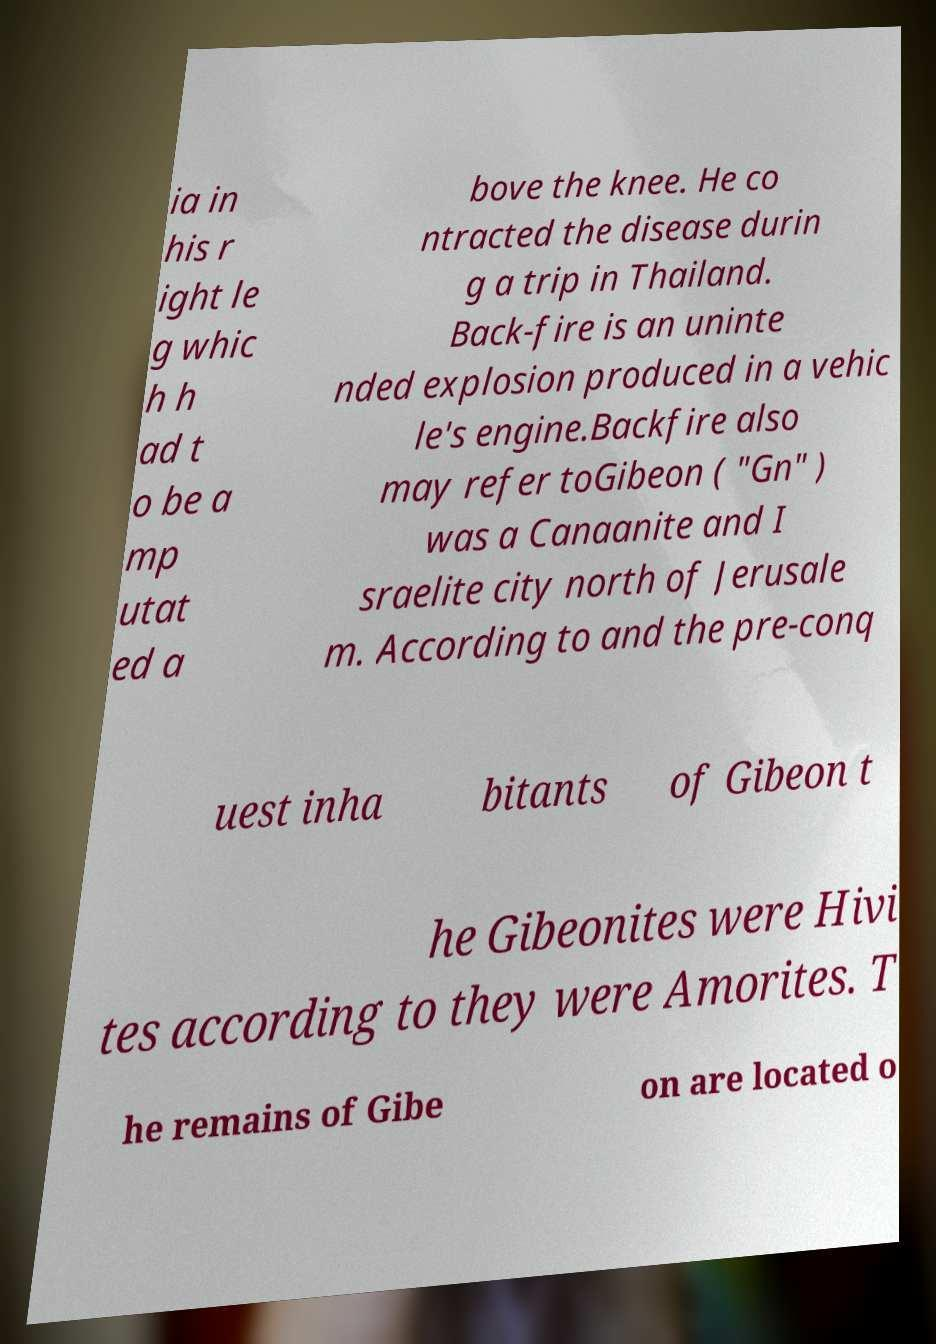Can you read and provide the text displayed in the image?This photo seems to have some interesting text. Can you extract and type it out for me? ia in his r ight le g whic h h ad t o be a mp utat ed a bove the knee. He co ntracted the disease durin g a trip in Thailand. Back-fire is an uninte nded explosion produced in a vehic le's engine.Backfire also may refer toGibeon ( "Gn" ) was a Canaanite and I sraelite city north of Jerusale m. According to and the pre-conq uest inha bitants of Gibeon t he Gibeonites were Hivi tes according to they were Amorites. T he remains of Gibe on are located o 